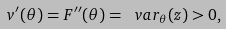<formula> <loc_0><loc_0><loc_500><loc_500>v { ^ { \prime } } ( \theta ) = F { ^ { \prime \prime } } ( \theta ) = \ v a r _ { \theta } ( z ) > 0 ,</formula> 